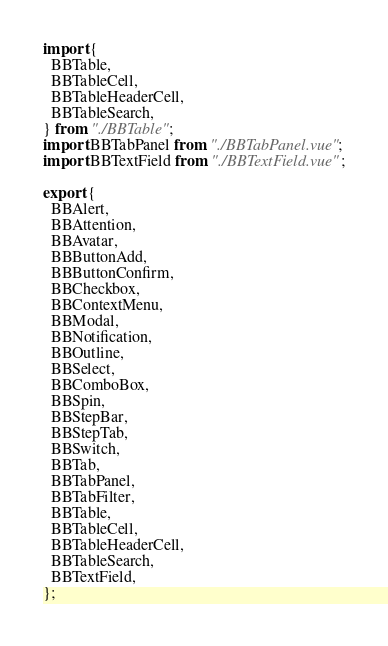Convert code to text. <code><loc_0><loc_0><loc_500><loc_500><_TypeScript_>import {
  BBTable,
  BBTableCell,
  BBTableHeaderCell,
  BBTableSearch,
} from "./BBTable";
import BBTabPanel from "./BBTabPanel.vue";
import BBTextField from "./BBTextField.vue";

export {
  BBAlert,
  BBAttention,
  BBAvatar,
  BBButtonAdd,
  BBButtonConfirm,
  BBCheckbox,
  BBContextMenu,
  BBModal,
  BBNotification,
  BBOutline,
  BBSelect,
  BBComboBox,
  BBSpin,
  BBStepBar,
  BBStepTab,
  BBSwitch,
  BBTab,
  BBTabPanel,
  BBTabFilter,
  BBTable,
  BBTableCell,
  BBTableHeaderCell,
  BBTableSearch,
  BBTextField,
};
</code> 